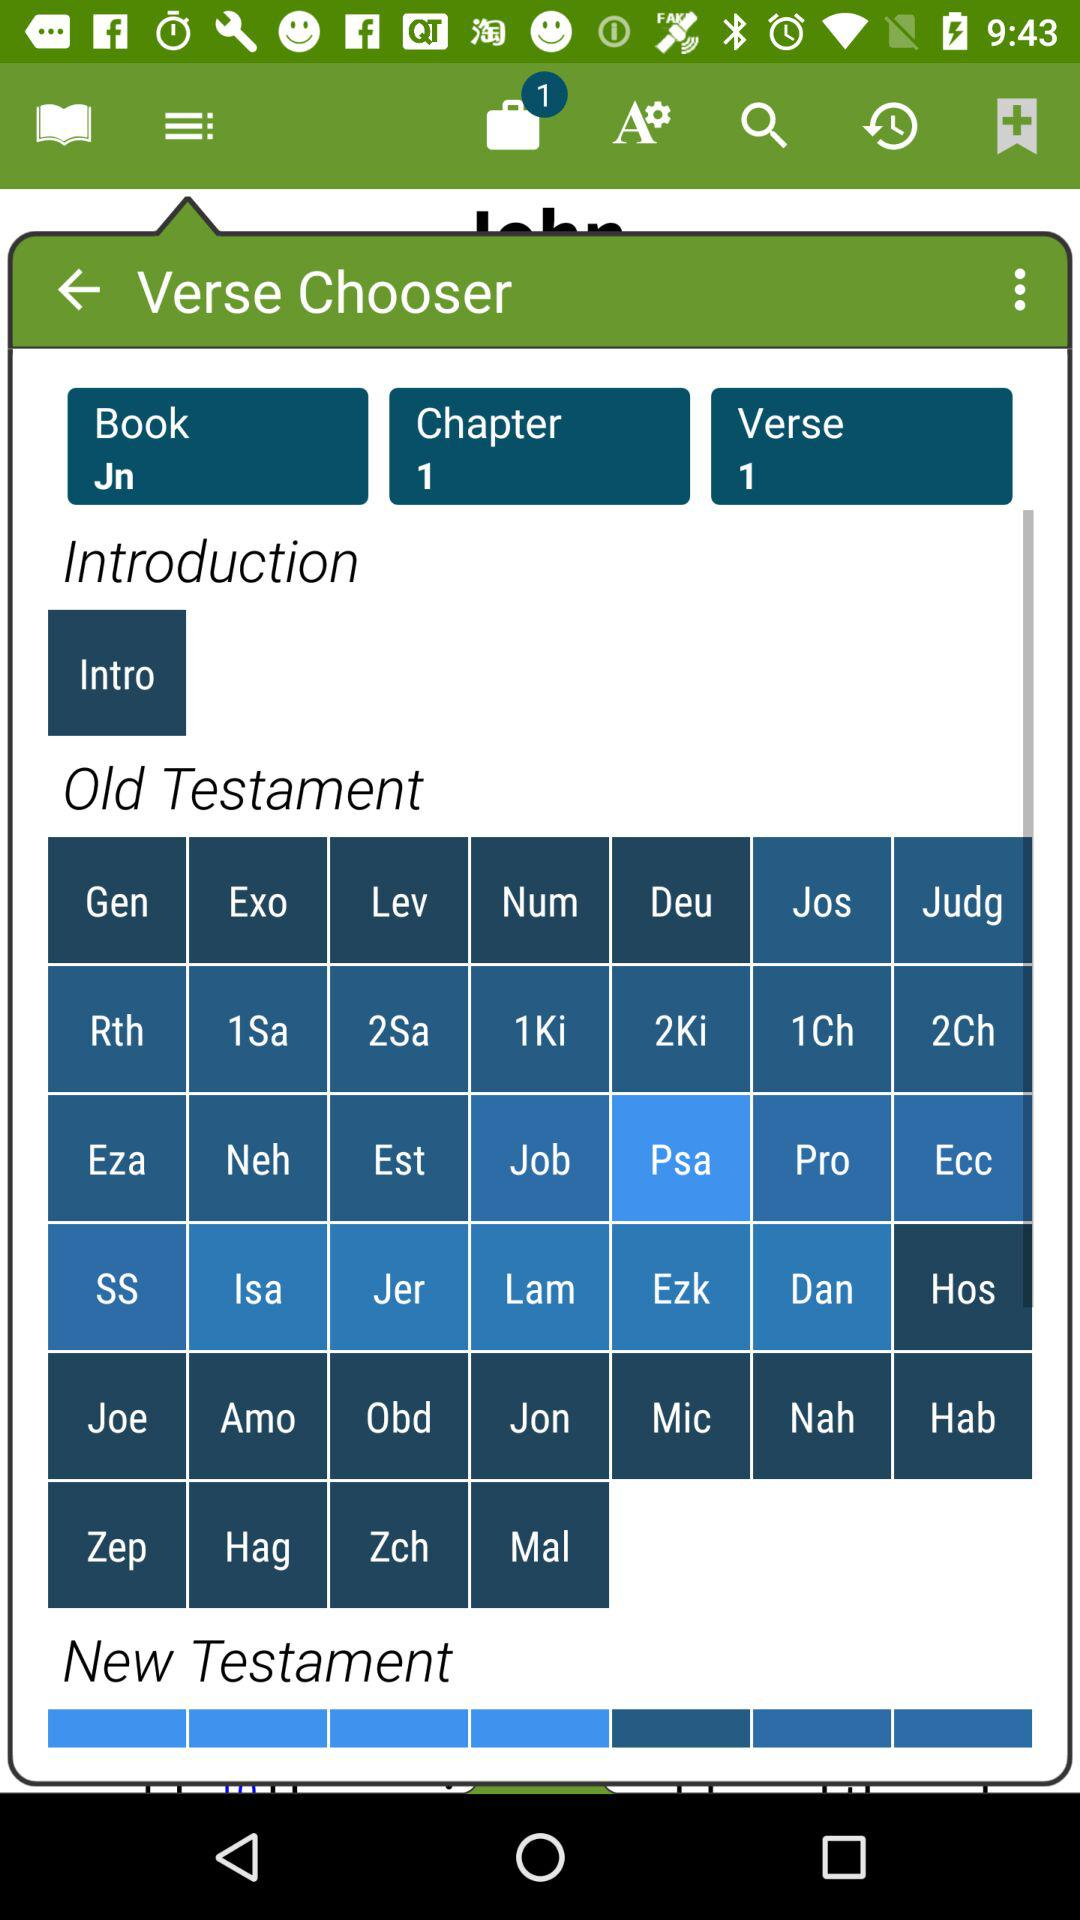How many verses are there? There is 1 verse. 